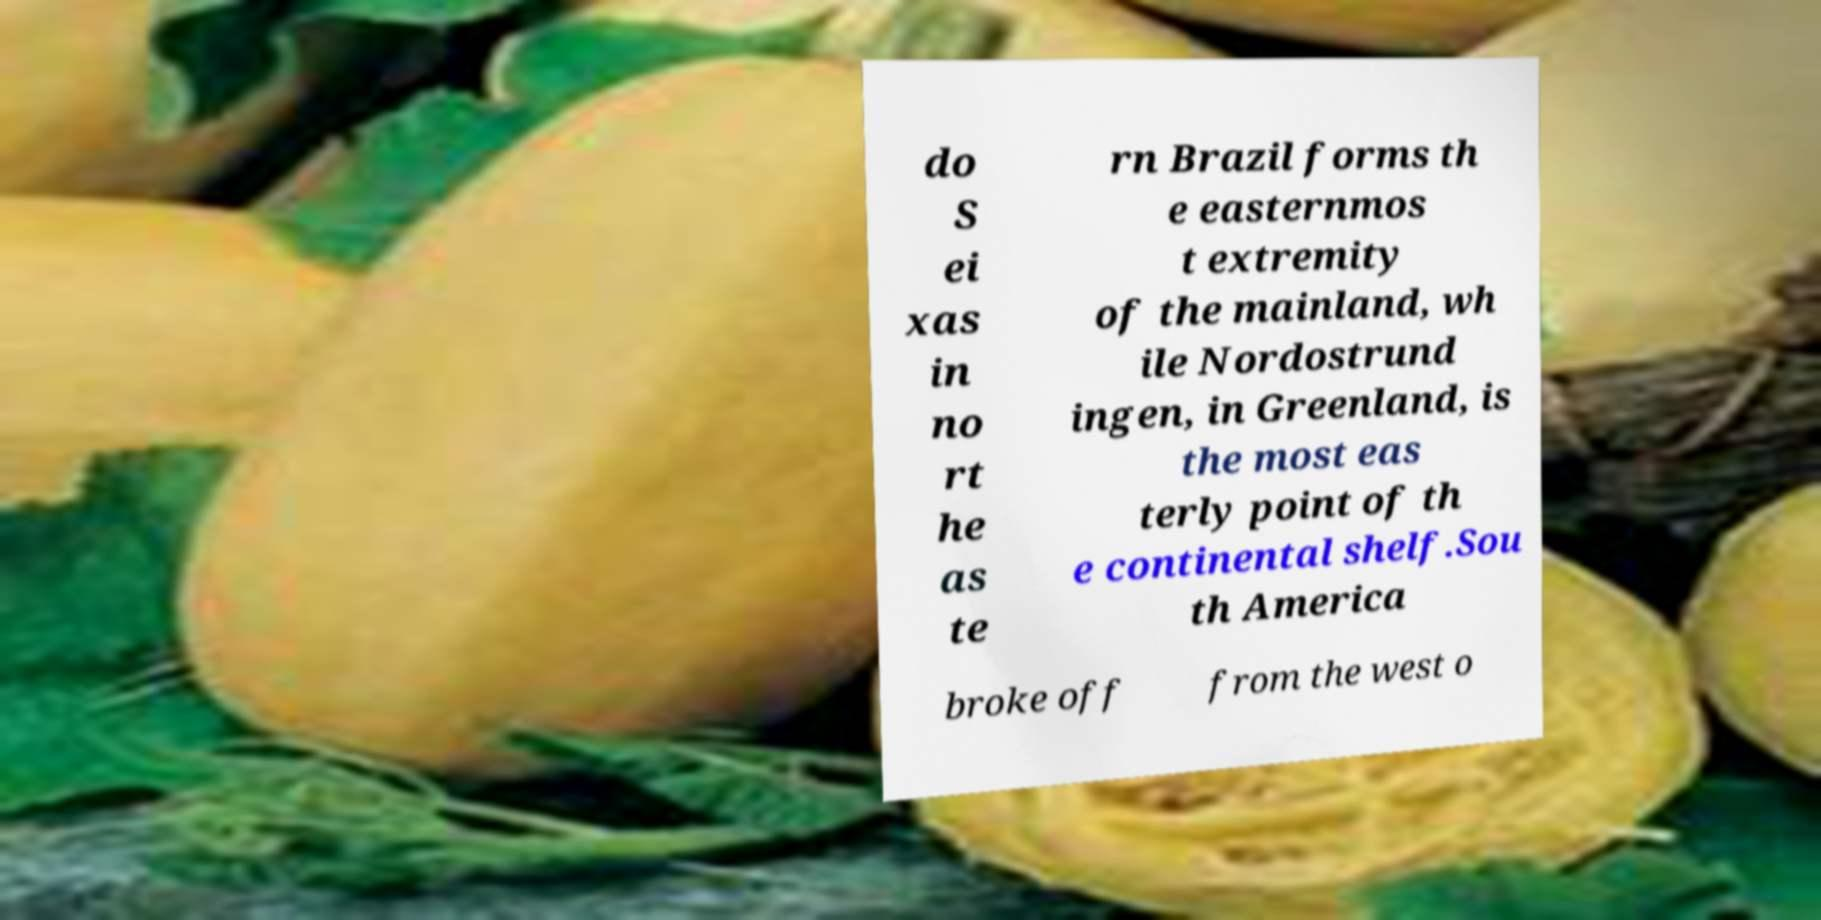Can you accurately transcribe the text from the provided image for me? do S ei xas in no rt he as te rn Brazil forms th e easternmos t extremity of the mainland, wh ile Nordostrund ingen, in Greenland, is the most eas terly point of th e continental shelf.Sou th America broke off from the west o 